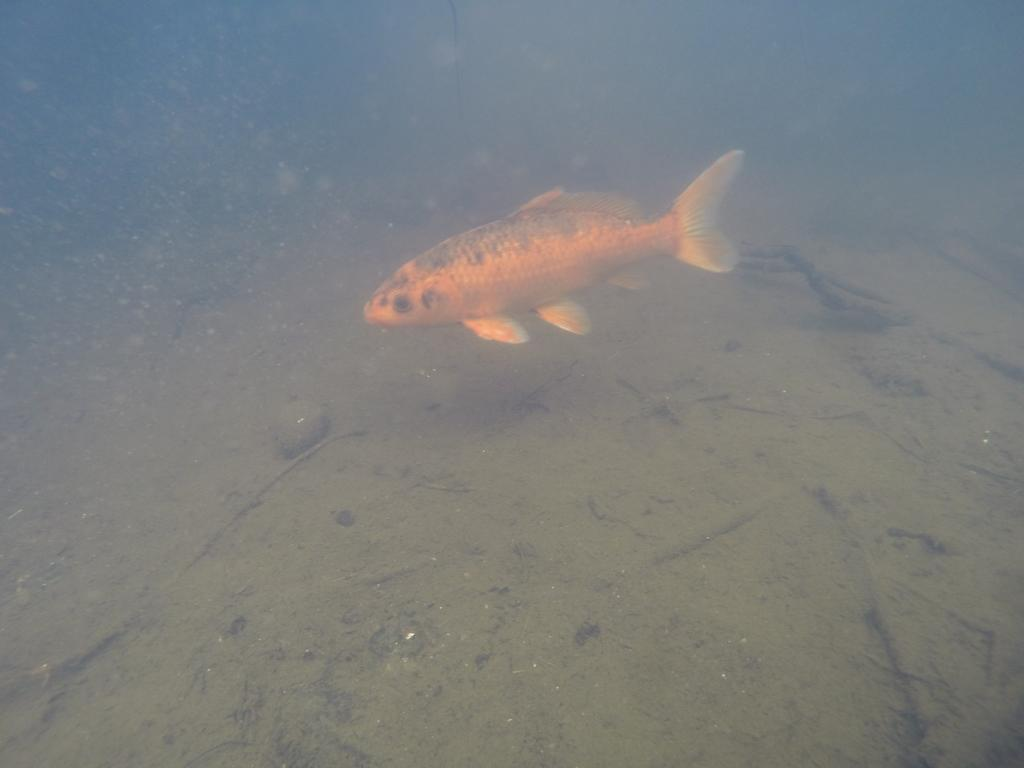What type of animal is in the image? There is an orange color fish in the image. Where is the fish located? The fish is inside the water. What type of terrain can be seen in the image? There is sand visible in the image. What other objects are present in the image? There are sticks and a stone in the image. What color is the background of the image? The background of the image is blue. What type of bread can be seen in the image? There is no bread present in the image. What level of expertise is required to handle the copper object in the image? There is no copper object present in the image. 